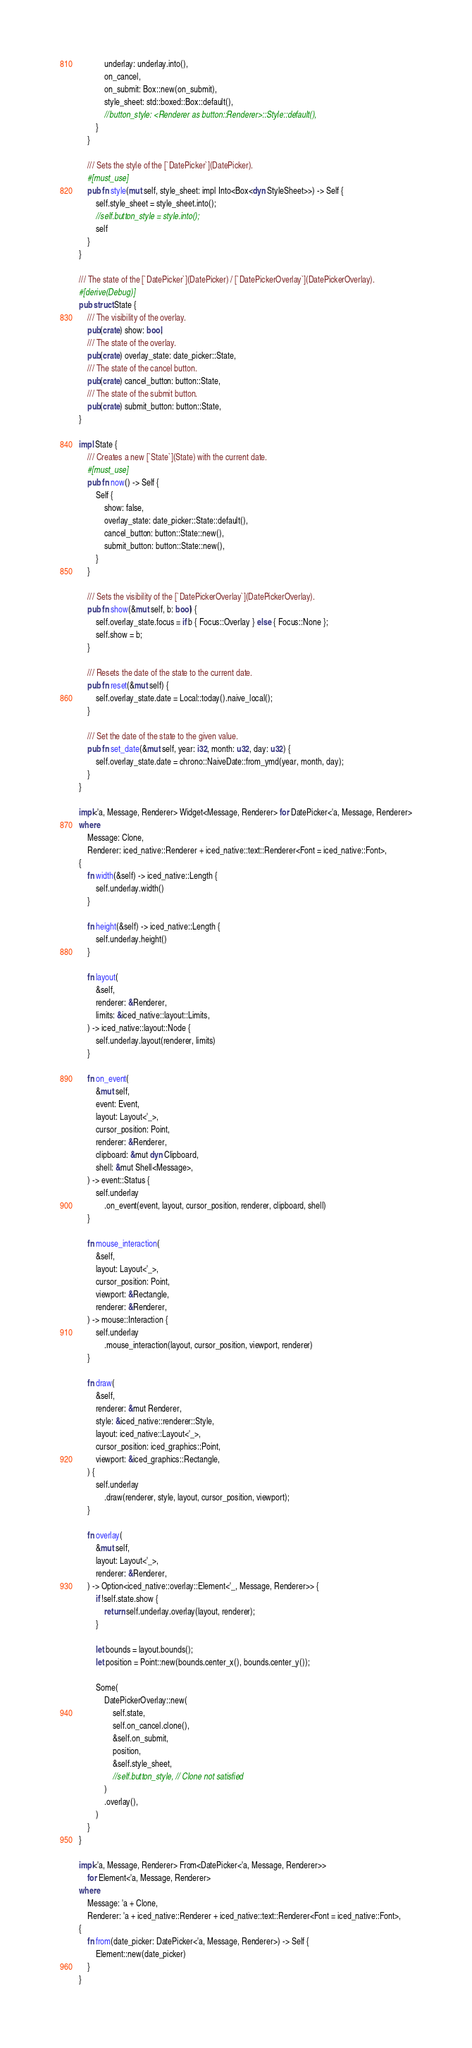Convert code to text. <code><loc_0><loc_0><loc_500><loc_500><_Rust_>            underlay: underlay.into(),
            on_cancel,
            on_submit: Box::new(on_submit),
            style_sheet: std::boxed::Box::default(),
            //button_style: <Renderer as button::Renderer>::Style::default(),
        }
    }

    /// Sets the style of the [`DatePicker`](DatePicker).
    #[must_use]
    pub fn style(mut self, style_sheet: impl Into<Box<dyn StyleSheet>>) -> Self {
        self.style_sheet = style_sheet.into();
        //self.button_style = style.into();
        self
    }
}

/// The state of the [`DatePicker`](DatePicker) / [`DatePickerOverlay`](DatePickerOverlay).
#[derive(Debug)]
pub struct State {
    /// The visibility of the overlay.
    pub(crate) show: bool,
    /// The state of the overlay.
    pub(crate) overlay_state: date_picker::State,
    /// The state of the cancel button.
    pub(crate) cancel_button: button::State,
    /// The state of the submit button.
    pub(crate) submit_button: button::State,
}

impl State {
    /// Creates a new [`State`](State) with the current date.
    #[must_use]
    pub fn now() -> Self {
        Self {
            show: false,
            overlay_state: date_picker::State::default(),
            cancel_button: button::State::new(),
            submit_button: button::State::new(),
        }
    }

    /// Sets the visibility of the [`DatePickerOverlay`](DatePickerOverlay).
    pub fn show(&mut self, b: bool) {
        self.overlay_state.focus = if b { Focus::Overlay } else { Focus::None };
        self.show = b;
    }

    /// Resets the date of the state to the current date.
    pub fn reset(&mut self) {
        self.overlay_state.date = Local::today().naive_local();
    }

    /// Set the date of the state to the given value.
    pub fn set_date(&mut self, year: i32, month: u32, day: u32) {
        self.overlay_state.date = chrono::NaiveDate::from_ymd(year, month, day);
    }
}

impl<'a, Message, Renderer> Widget<Message, Renderer> for DatePicker<'a, Message, Renderer>
where
    Message: Clone,
    Renderer: iced_native::Renderer + iced_native::text::Renderer<Font = iced_native::Font>,
{
    fn width(&self) -> iced_native::Length {
        self.underlay.width()
    }

    fn height(&self) -> iced_native::Length {
        self.underlay.height()
    }

    fn layout(
        &self,
        renderer: &Renderer,
        limits: &iced_native::layout::Limits,
    ) -> iced_native::layout::Node {
        self.underlay.layout(renderer, limits)
    }

    fn on_event(
        &mut self,
        event: Event,
        layout: Layout<'_>,
        cursor_position: Point,
        renderer: &Renderer,
        clipboard: &mut dyn Clipboard,
        shell: &mut Shell<Message>,
    ) -> event::Status {
        self.underlay
            .on_event(event, layout, cursor_position, renderer, clipboard, shell)
    }

    fn mouse_interaction(
        &self,
        layout: Layout<'_>,
        cursor_position: Point,
        viewport: &Rectangle,
        renderer: &Renderer,
    ) -> mouse::Interaction {
        self.underlay
            .mouse_interaction(layout, cursor_position, viewport, renderer)
    }

    fn draw(
        &self,
        renderer: &mut Renderer,
        style: &iced_native::renderer::Style,
        layout: iced_native::Layout<'_>,
        cursor_position: iced_graphics::Point,
        viewport: &iced_graphics::Rectangle,
    ) {
        self.underlay
            .draw(renderer, style, layout, cursor_position, viewport);
    }

    fn overlay(
        &mut self,
        layout: Layout<'_>,
        renderer: &Renderer,
    ) -> Option<iced_native::overlay::Element<'_, Message, Renderer>> {
        if !self.state.show {
            return self.underlay.overlay(layout, renderer);
        }

        let bounds = layout.bounds();
        let position = Point::new(bounds.center_x(), bounds.center_y());

        Some(
            DatePickerOverlay::new(
                self.state,
                self.on_cancel.clone(),
                &self.on_submit,
                position,
                &self.style_sheet,
                //self.button_style, // Clone not satisfied
            )
            .overlay(),
        )
    }
}

impl<'a, Message, Renderer> From<DatePicker<'a, Message, Renderer>>
    for Element<'a, Message, Renderer>
where
    Message: 'a + Clone,
    Renderer: 'a + iced_native::Renderer + iced_native::text::Renderer<Font = iced_native::Font>,
{
    fn from(date_picker: DatePicker<'a, Message, Renderer>) -> Self {
        Element::new(date_picker)
    }
}
</code> 